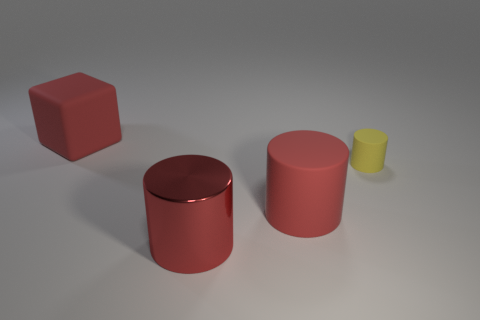Is there a cube that has the same color as the large metal thing?
Your answer should be compact. Yes. There is a object to the left of the big red metal cylinder; does it have the same color as the large cylinder behind the large red metallic thing?
Provide a short and direct response. Yes. Are there fewer big things behind the red rubber cylinder than large red cylinders?
Give a very brief answer. Yes. What number of objects are either large shiny things or cylinders that are in front of the block?
Ensure brevity in your answer.  3. There is a large cube that is the same material as the tiny object; what color is it?
Provide a succinct answer. Red. How many things are either red rubber blocks or big blue cylinders?
Your answer should be compact. 1. There is a rubber object that is the same size as the red block; what color is it?
Your answer should be compact. Red. How many things are red things behind the metal object or large red things?
Your answer should be very brief. 3. How many other objects are the same size as the red metallic object?
Keep it short and to the point. 2. What is the size of the red matte thing in front of the big block?
Your response must be concise. Large. 